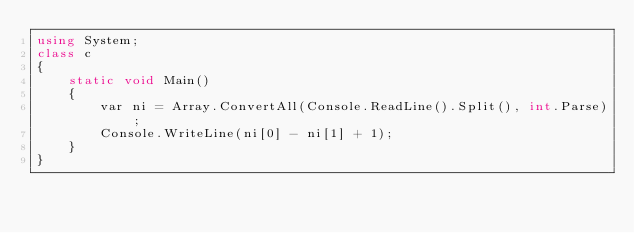Convert code to text. <code><loc_0><loc_0><loc_500><loc_500><_C#_>using System;
class c
{
    static void Main()
    {
        var ni = Array.ConvertAll(Console.ReadLine().Split(), int.Parse);
        Console.WriteLine(ni[0] - ni[1] + 1);
    }
}</code> 